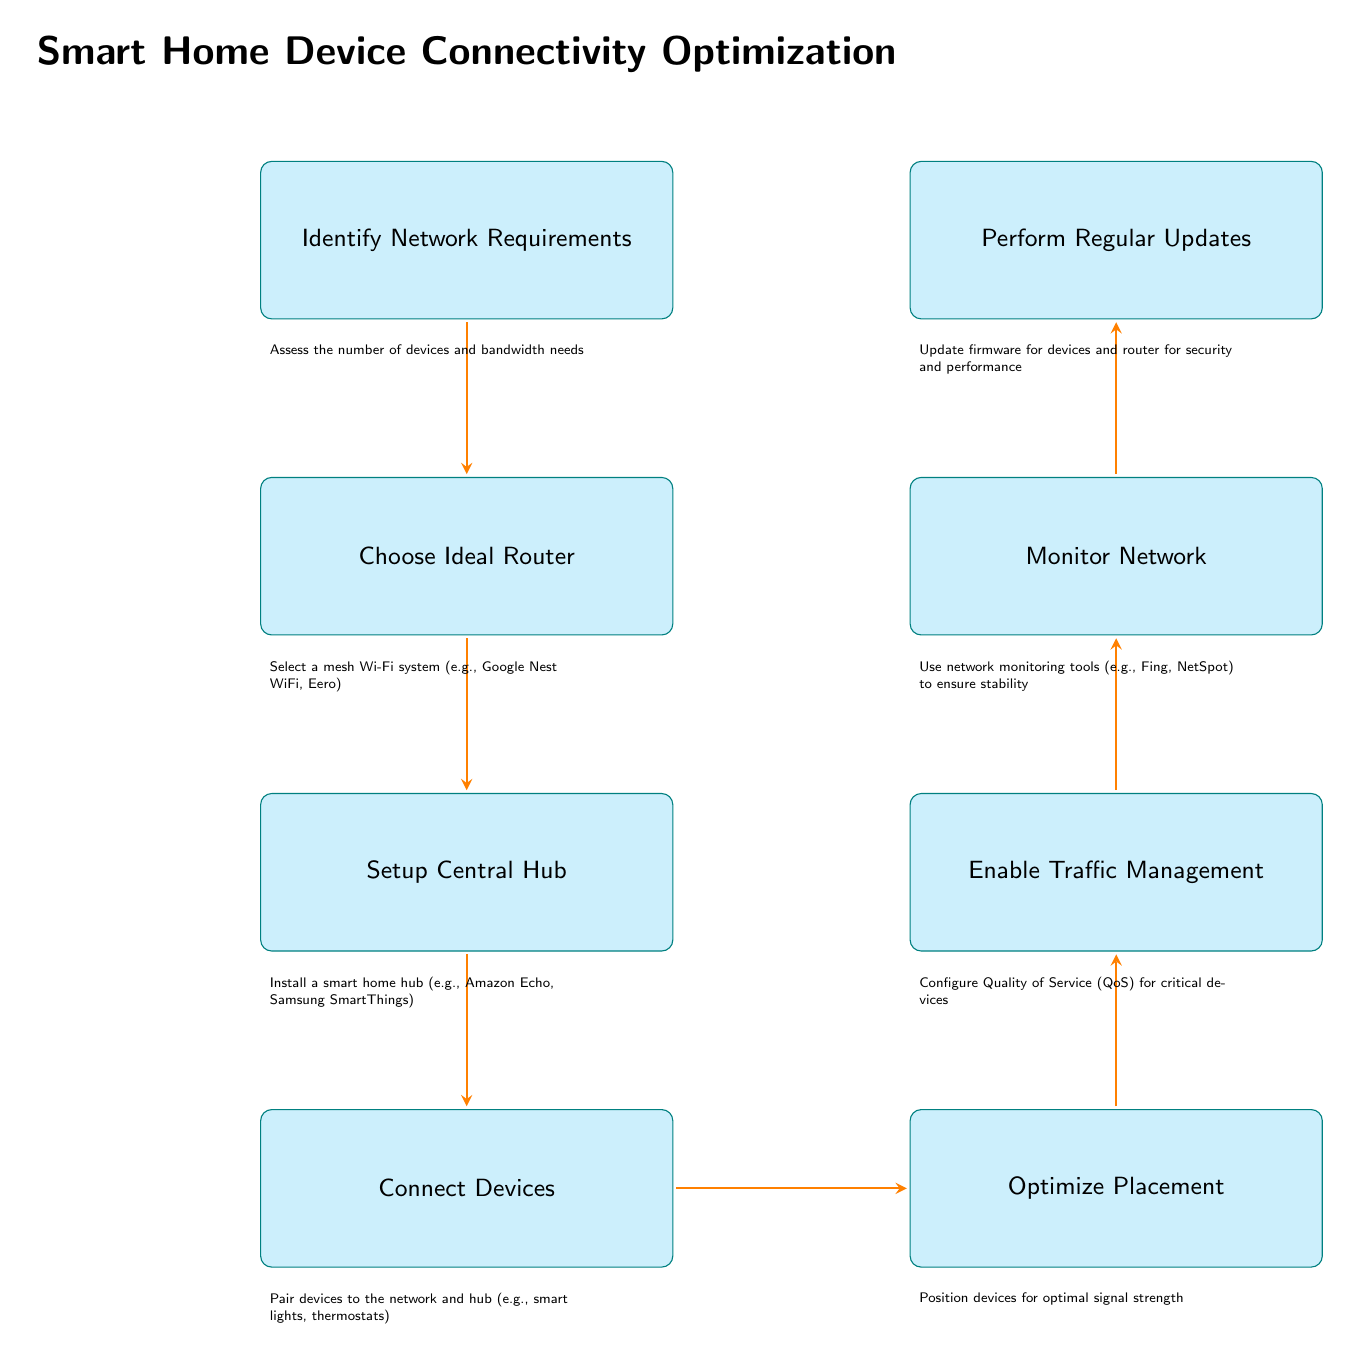What is the first step in the flow chart? The first step is "Identify Network Requirements," which is the top node in the flow chart and the starting point for optimization of smart home device connectivity.
Answer: Identify Network Requirements How many steps are in the flow chart? There are a total of eight steps in the flow chart, starting from "Identify Network Requirements" and ending with "Perform Regular Updates."
Answer: Eight What is the last step of the process? The last step in the flow chart is "Perform Regular Updates," which indicates updating firmware for security and performance.
Answer: Perform Regular Updates Which step involves setting up a smart home hub? The step that involves this action is "Setup Central Hub," which is positioned directly after "Choose Ideal Router."
Answer: Setup Central Hub What does the "Enable Traffic Management" step focus on? This step focuses on configuring Quality of Service (QoS) for critical devices to ensure their traffic is prioritized in the network.
Answer: Configure Quality of Service What is the relationship between "Connect Devices" and "Optimize Placement"? "Connect Devices" is directly followed by "Optimize Placement," meaning that once devices are paired to the network and hub, their physical placement is then optimized for signal strength.
Answer: Directly followed What tool types are suggested for monitoring the network? The suggested tool types in the "Monitor Network" step are network monitoring tools, specifically mentioned are Fing and NetSpot.
Answer: Network monitoring tools Which steps require actions related to devices? Steps that require such actions are "Setup Central Hub," "Connect Devices," "Enable Traffic Management," and "Perform Regular Updates," as they all involve actions that either relate to device installation or maintenance.
Answer: Four steps Why is it important to "Optimize Placement"? It is important to optimize placement to ensure the devices have optimal signal strength, which can improve their performance and connectivity in the smart home setup.
Answer: Optimal signal strength 